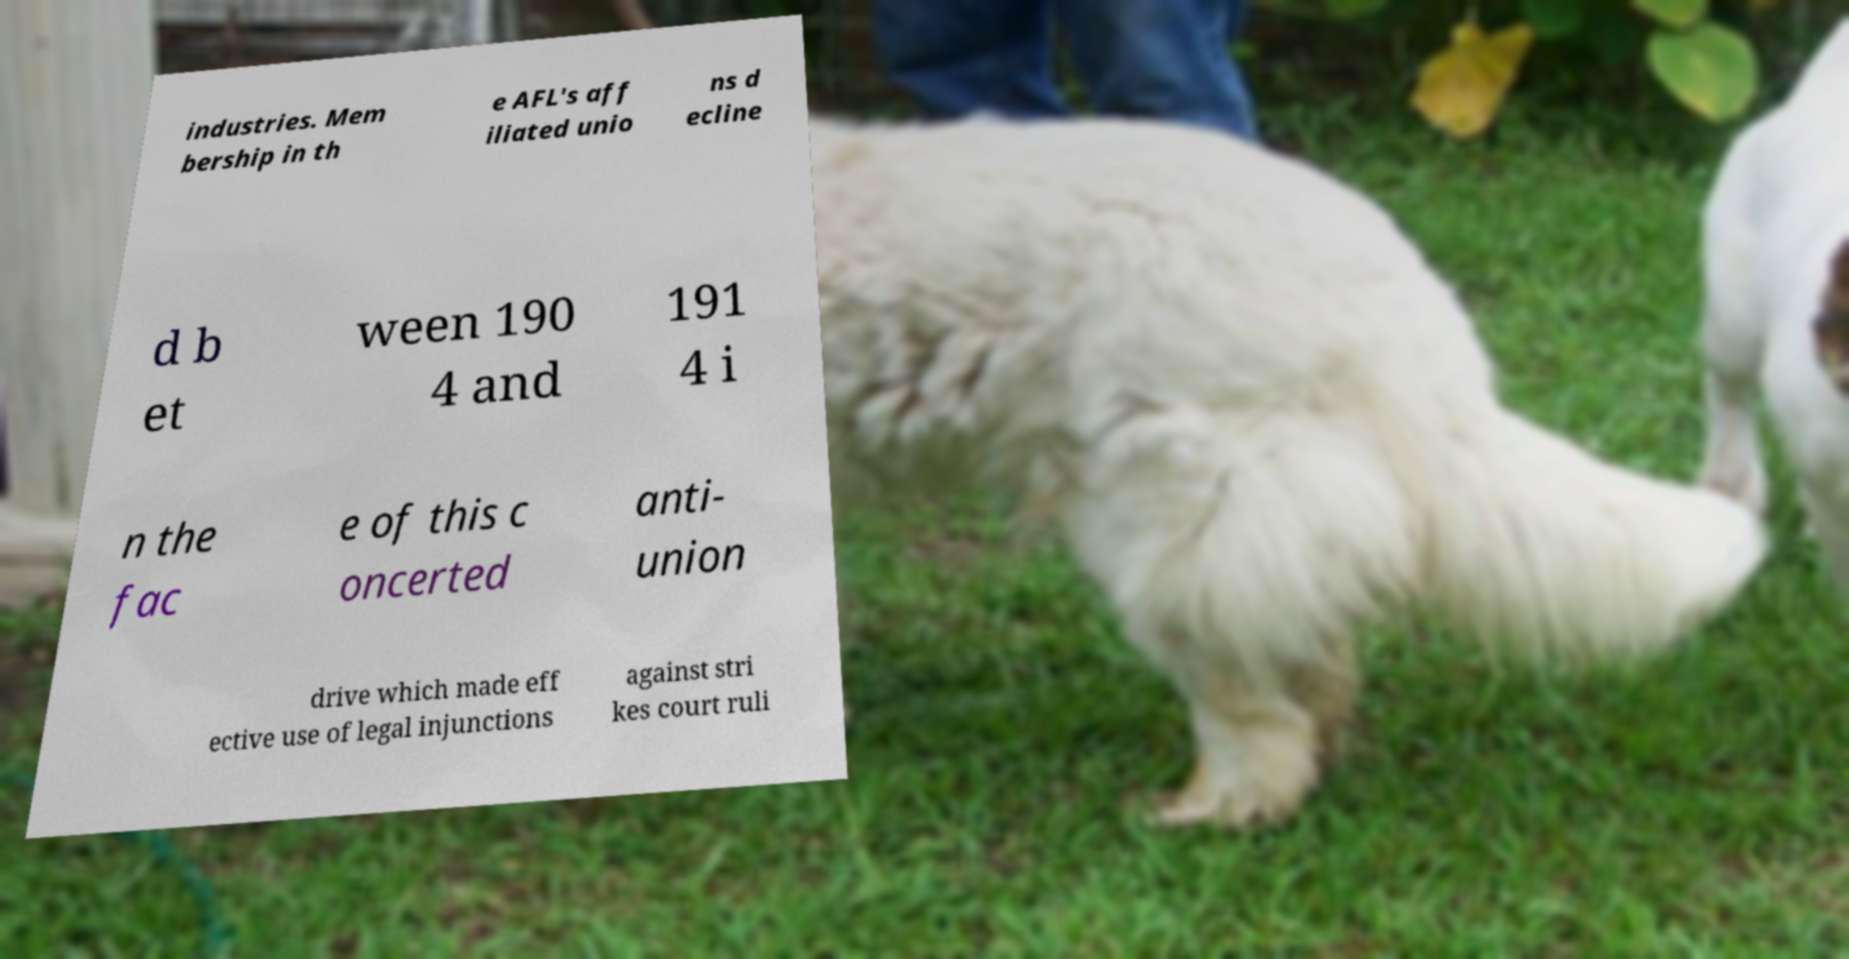Can you read and provide the text displayed in the image?This photo seems to have some interesting text. Can you extract and type it out for me? industries. Mem bership in th e AFL's aff iliated unio ns d ecline d b et ween 190 4 and 191 4 i n the fac e of this c oncerted anti- union drive which made eff ective use of legal injunctions against stri kes court ruli 